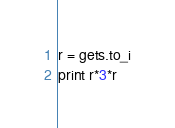<code> <loc_0><loc_0><loc_500><loc_500><_Ruby_>r = gets.to_i
print r*3*r</code> 